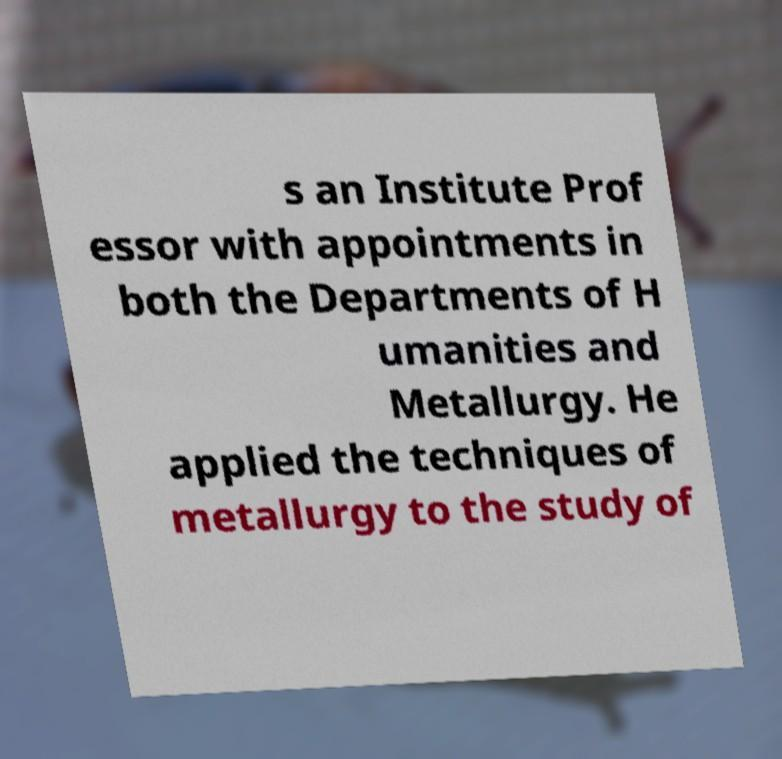Could you assist in decoding the text presented in this image and type it out clearly? s an Institute Prof essor with appointments in both the Departments of H umanities and Metallurgy. He applied the techniques of metallurgy to the study of 